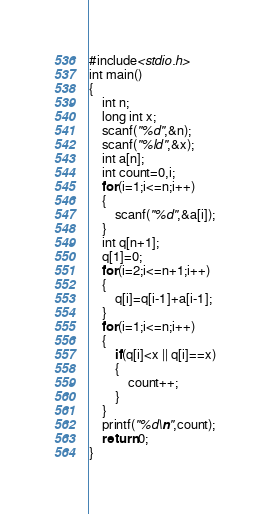Convert code to text. <code><loc_0><loc_0><loc_500><loc_500><_C_>#include<stdio.h>
int main()
{
    int n;
    long int x;
    scanf("%d",&n);
    scanf("%ld",&x);
    int a[n];
    int count=0,i;
    for(i=1;i<=n;i++)
    {
        scanf("%d",&a[i]);
    }
    int q[n+1];
    q[1]=0;
    for(i=2;i<=n+1;i++)
    {
        q[i]=q[i-1]+a[i-1];
    }
    for(i=1;i<=n;i++)
    {
        if(q[i]<x || q[i]==x)
        {
            count++;
        }
    }
    printf("%d\n",count);
    return 0;
}
</code> 